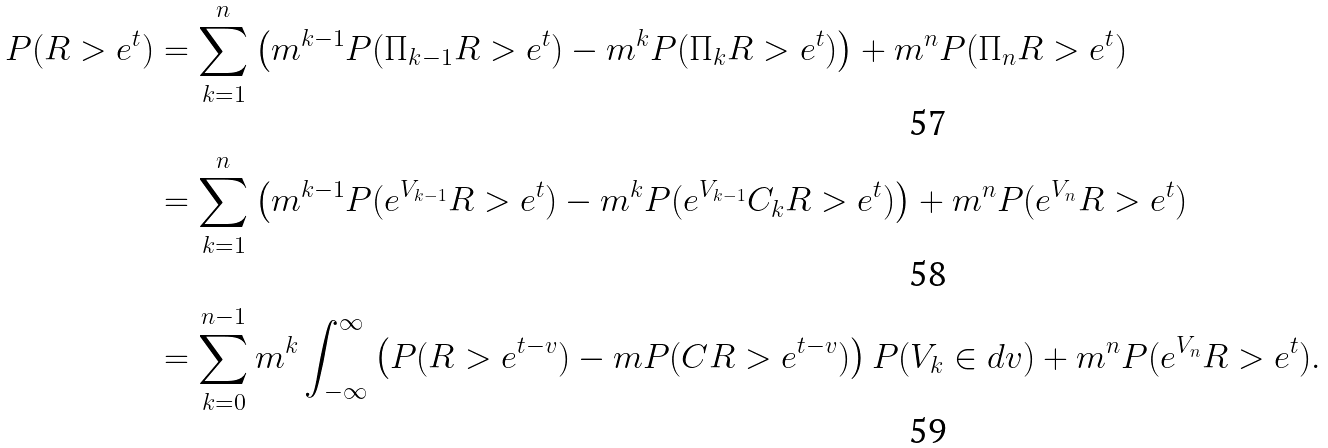<formula> <loc_0><loc_0><loc_500><loc_500>P ( R > e ^ { t } ) & = \sum _ { k = 1 } ^ { n } \left ( m ^ { k - 1 } P ( \Pi _ { k - 1 } R > e ^ { t } ) - m ^ { k } P ( \Pi _ { k } R > e ^ { t } ) \right ) + m ^ { n } P ( \Pi _ { n } R > e ^ { t } ) \\ & = \sum _ { k = 1 } ^ { n } \left ( m ^ { k - 1 } P ( e ^ { V _ { k - 1 } } R > e ^ { t } ) - m ^ { k } P ( e ^ { V _ { k - 1 } } C _ { k } R > e ^ { t } ) \right ) + m ^ { n } P ( e ^ { V _ { n } } R > e ^ { t } ) \\ & = \sum _ { k = 0 } ^ { n - 1 } m ^ { k } \int _ { - \infty } ^ { \infty } \left ( P ( R > e ^ { t - v } ) - m P ( C R > e ^ { t - v } ) \right ) P ( V _ { k } \in d v ) + m ^ { n } P ( e ^ { V _ { n } } R > e ^ { t } ) .</formula> 